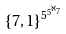<formula> <loc_0><loc_0><loc_500><loc_500>\{ 7 , 1 \} ^ { 5 ^ { 5 ^ { \aleph _ { 7 } } } }</formula> 